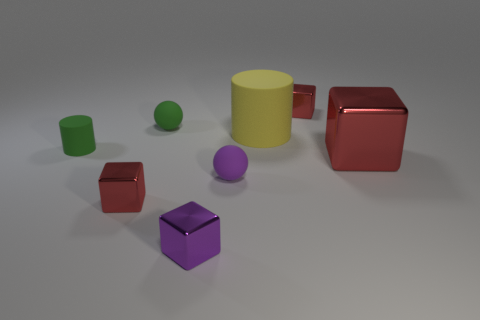Subtract all large cubes. How many cubes are left? 3 Add 1 small purple shiny blocks. How many objects exist? 9 Subtract all purple cubes. How many cubes are left? 3 Subtract all cylinders. How many objects are left? 6 Subtract 1 cylinders. How many cylinders are left? 1 Subtract all big red rubber cylinders. Subtract all tiny red objects. How many objects are left? 6 Add 8 small red shiny cubes. How many small red shiny cubes are left? 10 Add 5 tiny green matte spheres. How many tiny green matte spheres exist? 6 Subtract 0 cyan cylinders. How many objects are left? 8 Subtract all yellow cylinders. Subtract all red blocks. How many cylinders are left? 1 